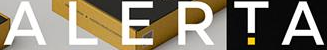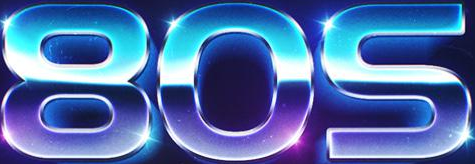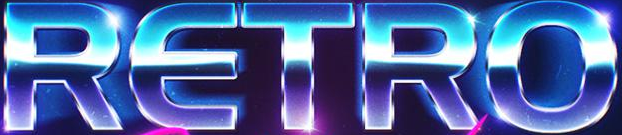What words are shown in these images in order, separated by a semicolon? ALERTA; 80S; RETRO 